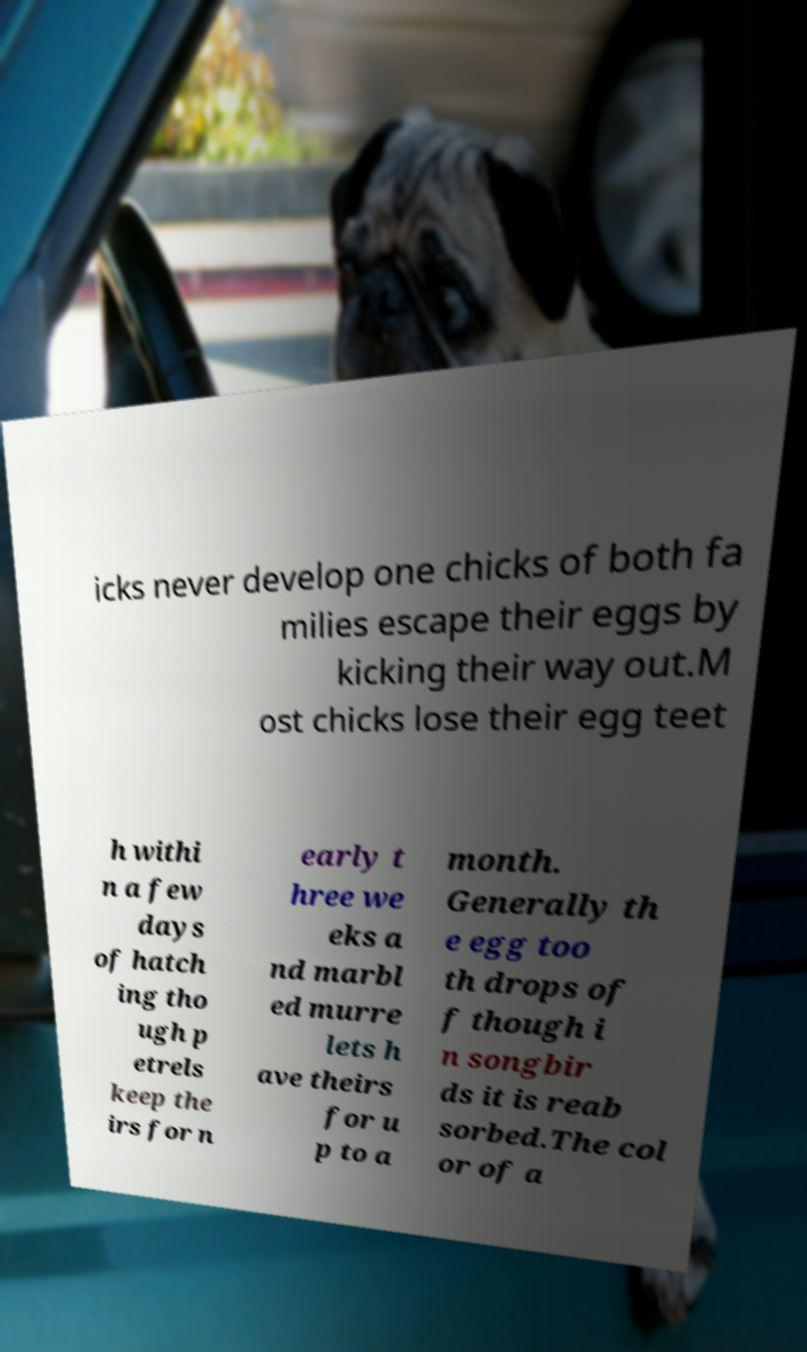Please identify and transcribe the text found in this image. icks never develop one chicks of both fa milies escape their eggs by kicking their way out.M ost chicks lose their egg teet h withi n a few days of hatch ing tho ugh p etrels keep the irs for n early t hree we eks a nd marbl ed murre lets h ave theirs for u p to a month. Generally th e egg too th drops of f though i n songbir ds it is reab sorbed.The col or of a 